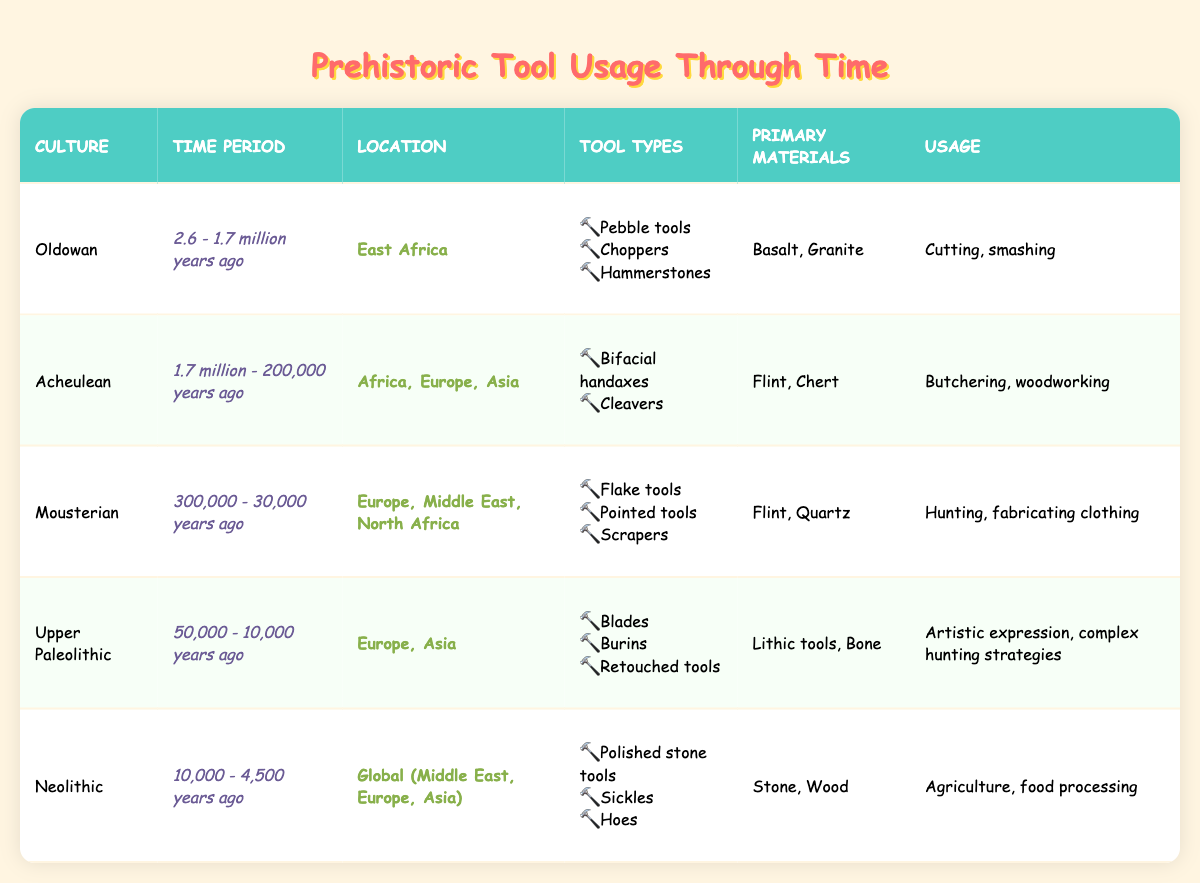What types of tools were used in the Oldowan culture? In the table, under the "Tool Types" column for the Oldowan culture, the listed tools are pebble tools, choppers, and hammerstones.
Answer: Pebble tools, choppers, hammerstones Which culture used bifacial handaxes as a tool type? Looking at the table, under the "Tool Types" column, bifacial handaxes are mentioned in the Acheulean culture's row.
Answer: Acheulean What was the primary material used for tools in the Upper Paleolithic culture? In the table, the "Primary Materials" column for the Upper Paleolithic culture indicates that lithic tools and bone were the main materials used.
Answer: Lithic tools, Bone Were the tools used in the Neolithic period primarily for hunting? In the table, under the "Usage" column for the Neolithic culture, the usage is listed as agriculture and food processing, not hunting. Therefore, the answer is no.
Answer: No How many different tool types were listed for the Mousterian culture? The table entry for the Mousterian culture lists three types of tools: flake tools, pointed tools, and scrapers. Thus, the total number of different tool types is three.
Answer: 3 What is the usage of tools in the Upper Paleolithic culture? In the "Usage" column for the Upper Paleolithic culture, the specified usages are artistic expression and complex hunting strategies.
Answer: Artistic expression, complex hunting strategies Which period covers the longest time frame based on the table? Analyzing the time periods, the Acheulean culture spans from 1.7 million to 200,000 years ago (1.5 million years), while the Oldowan spans 900,000 years and the Neolithic spans 5,500 years. The Acheulean period has the longest time frame.
Answer: Acheulean What locations did the Mousterian culture inhabit? In the table, the "Location" column for the Mousterian culture mentions Europe, the Middle East, and North Africa as its inhabited regions.
Answer: Europe, Middle East, North Africa Do any cultures listed primarily used stone and wood as primary materials? In the table, the Neolithic culture is the only one that primarily used stone and wood as indicated in the "Primary Materials" column. Therefore, the answer is yes.
Answer: Yes What is the relationship between tool types and the usage for the Acheulean culture? The Acheulean culture shows that bifacial handaxes and cleavers were used primarily for butchering and woodworking, indicating that the tool types support specific activities. The tools are effective for their described uses, forming a clear relationship.
Answer: Tools support specific uses 